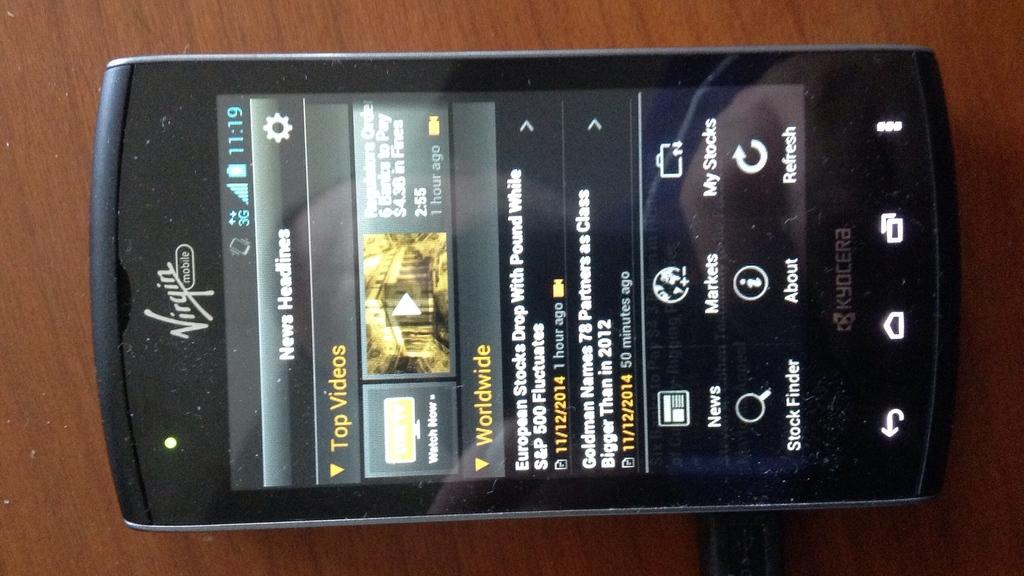What brand of phone?
Provide a short and direct response. Kyocera. Is top videos the first menu box?
Ensure brevity in your answer.  Yes. 